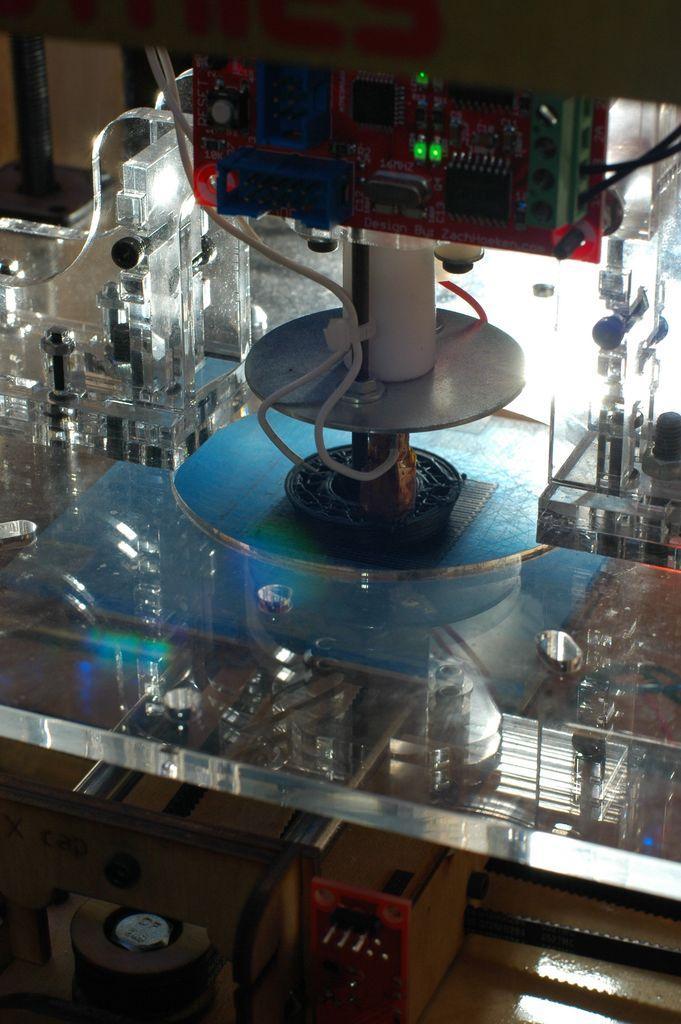Can you describe this image briefly? In this image this looks like an electronic device with the stand which is placed on the glass table. These are the wire, which are white in color. 